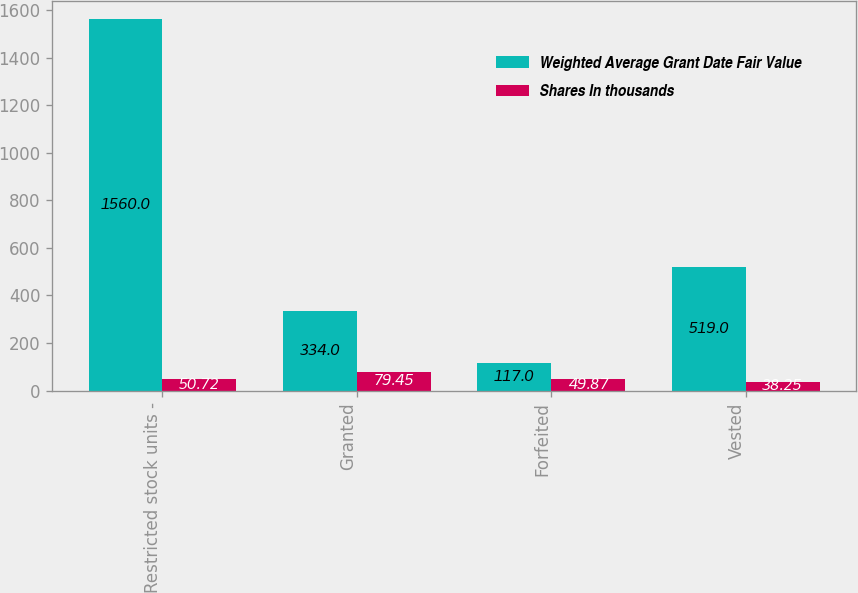<chart> <loc_0><loc_0><loc_500><loc_500><stacked_bar_chart><ecel><fcel>Restricted stock units -<fcel>Granted<fcel>Forfeited<fcel>Vested<nl><fcel>Weighted Average Grant Date Fair Value<fcel>1560<fcel>334<fcel>117<fcel>519<nl><fcel>Shares In thousands<fcel>50.72<fcel>79.45<fcel>49.87<fcel>38.25<nl></chart> 